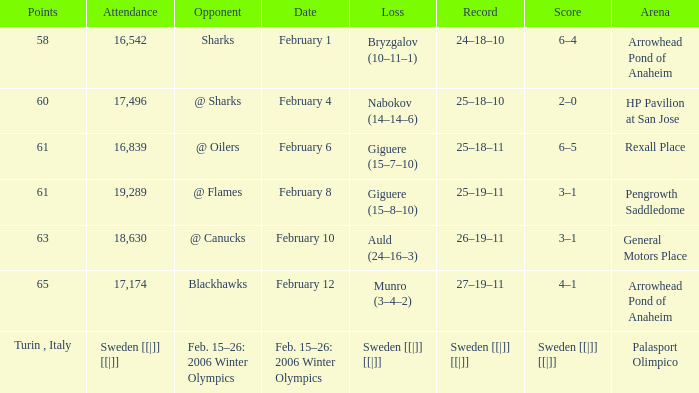What is the record at Arrowhead Pond of Anaheim, when the loss was Bryzgalov (10–11–1)? 24–18–10. 